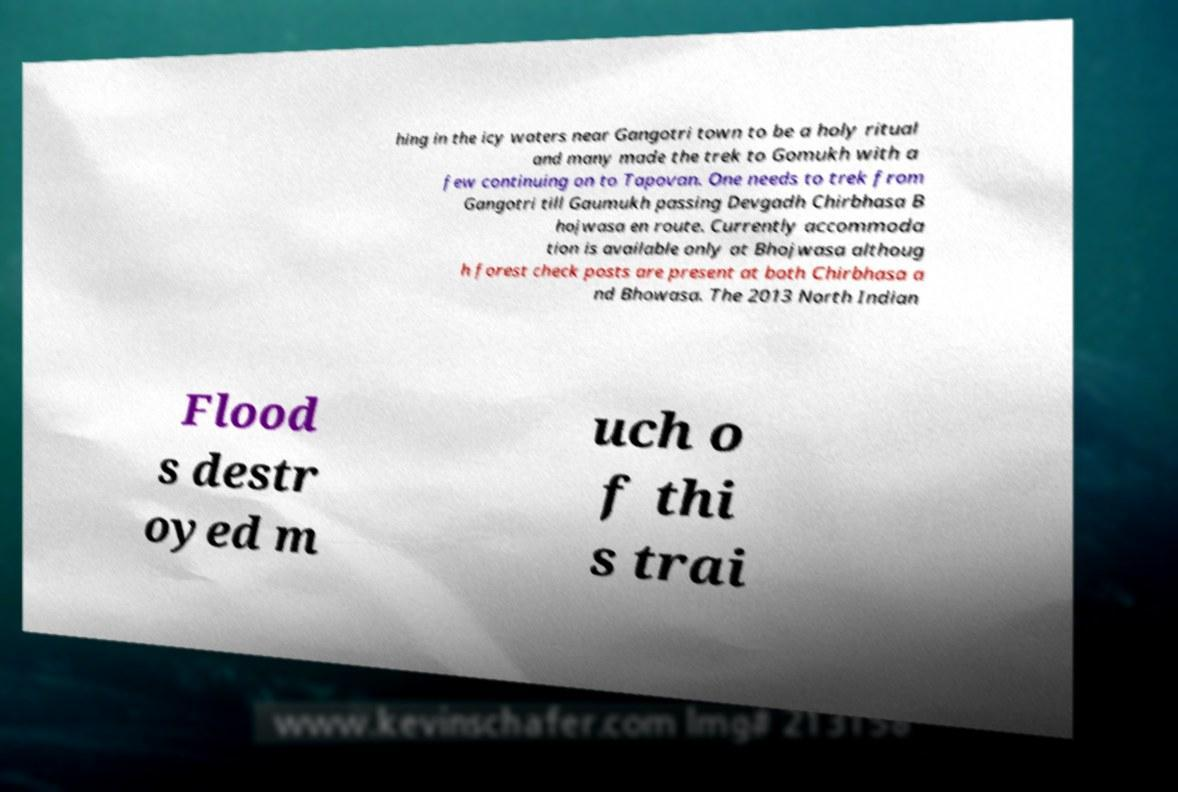Could you assist in decoding the text presented in this image and type it out clearly? hing in the icy waters near Gangotri town to be a holy ritual and many made the trek to Gomukh with a few continuing on to Tapovan. One needs to trek from Gangotri till Gaumukh passing Devgadh Chirbhasa B hojwasa en route. Currently accommoda tion is available only at Bhojwasa althoug h forest check posts are present at both Chirbhasa a nd Bhowasa. The 2013 North Indian Flood s destr oyed m uch o f thi s trai 